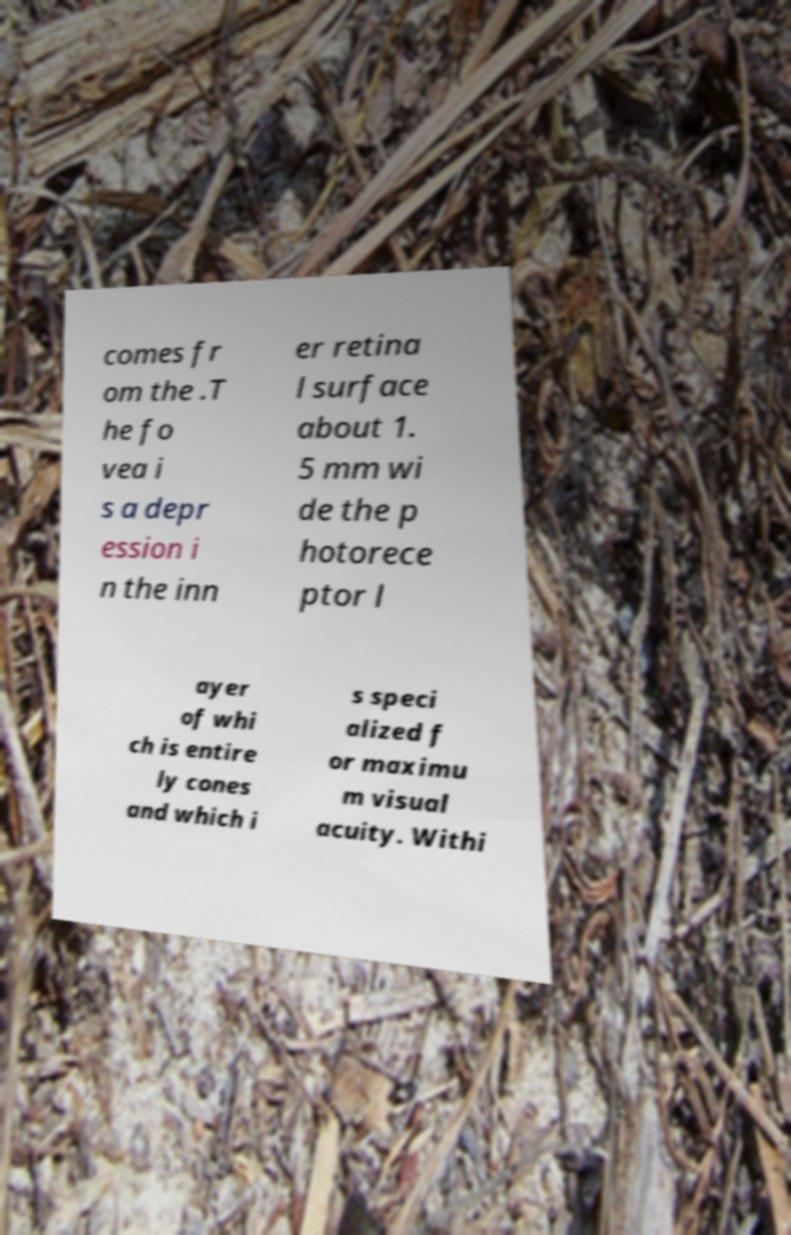I need the written content from this picture converted into text. Can you do that? comes fr om the .T he fo vea i s a depr ession i n the inn er retina l surface about 1. 5 mm wi de the p hotorece ptor l ayer of whi ch is entire ly cones and which i s speci alized f or maximu m visual acuity. Withi 